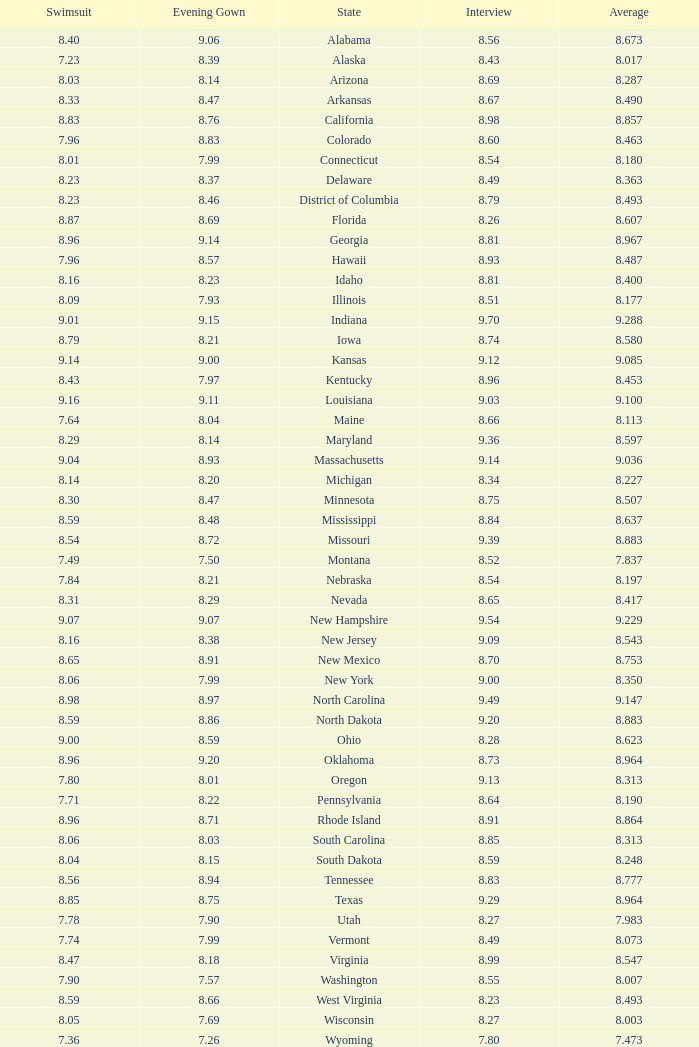Tell me the sum of interview for evening gown more than 8.37 and average of 8.363 None. 